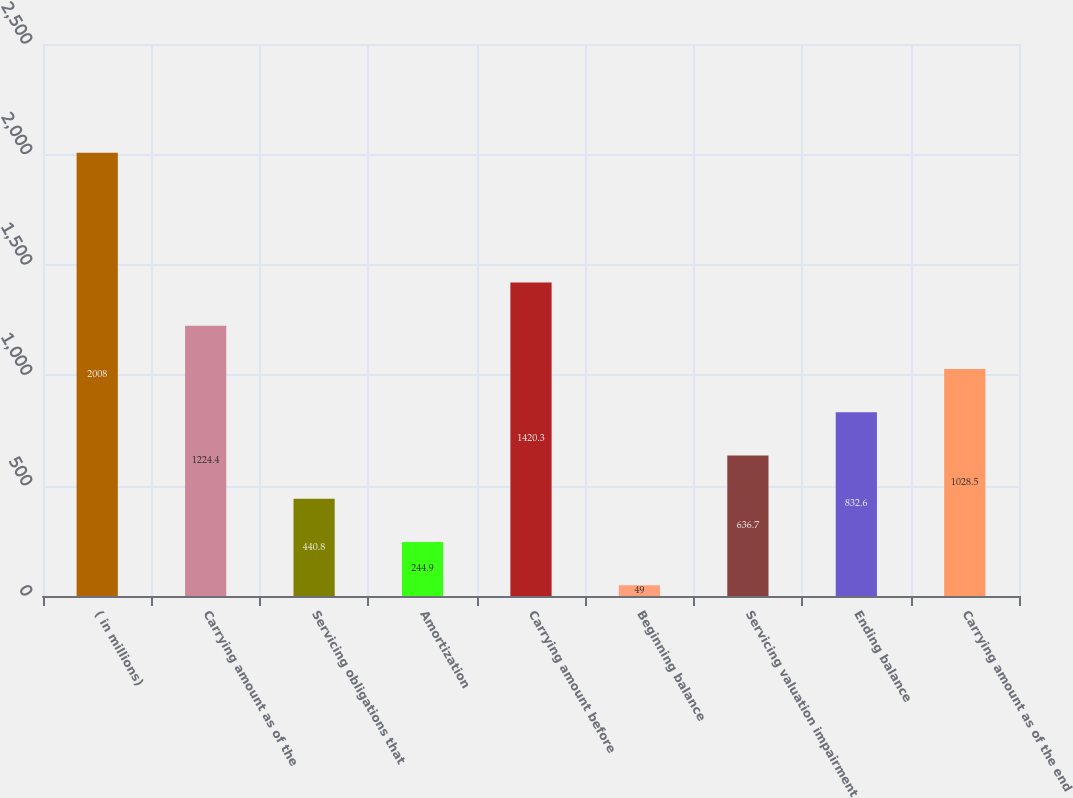Convert chart to OTSL. <chart><loc_0><loc_0><loc_500><loc_500><bar_chart><fcel>( in millions)<fcel>Carrying amount as of the<fcel>Servicing obligations that<fcel>Amortization<fcel>Carrying amount before<fcel>Beginning balance<fcel>Servicing valuation impairment<fcel>Ending balance<fcel>Carrying amount as of the end<nl><fcel>2008<fcel>1224.4<fcel>440.8<fcel>244.9<fcel>1420.3<fcel>49<fcel>636.7<fcel>832.6<fcel>1028.5<nl></chart> 